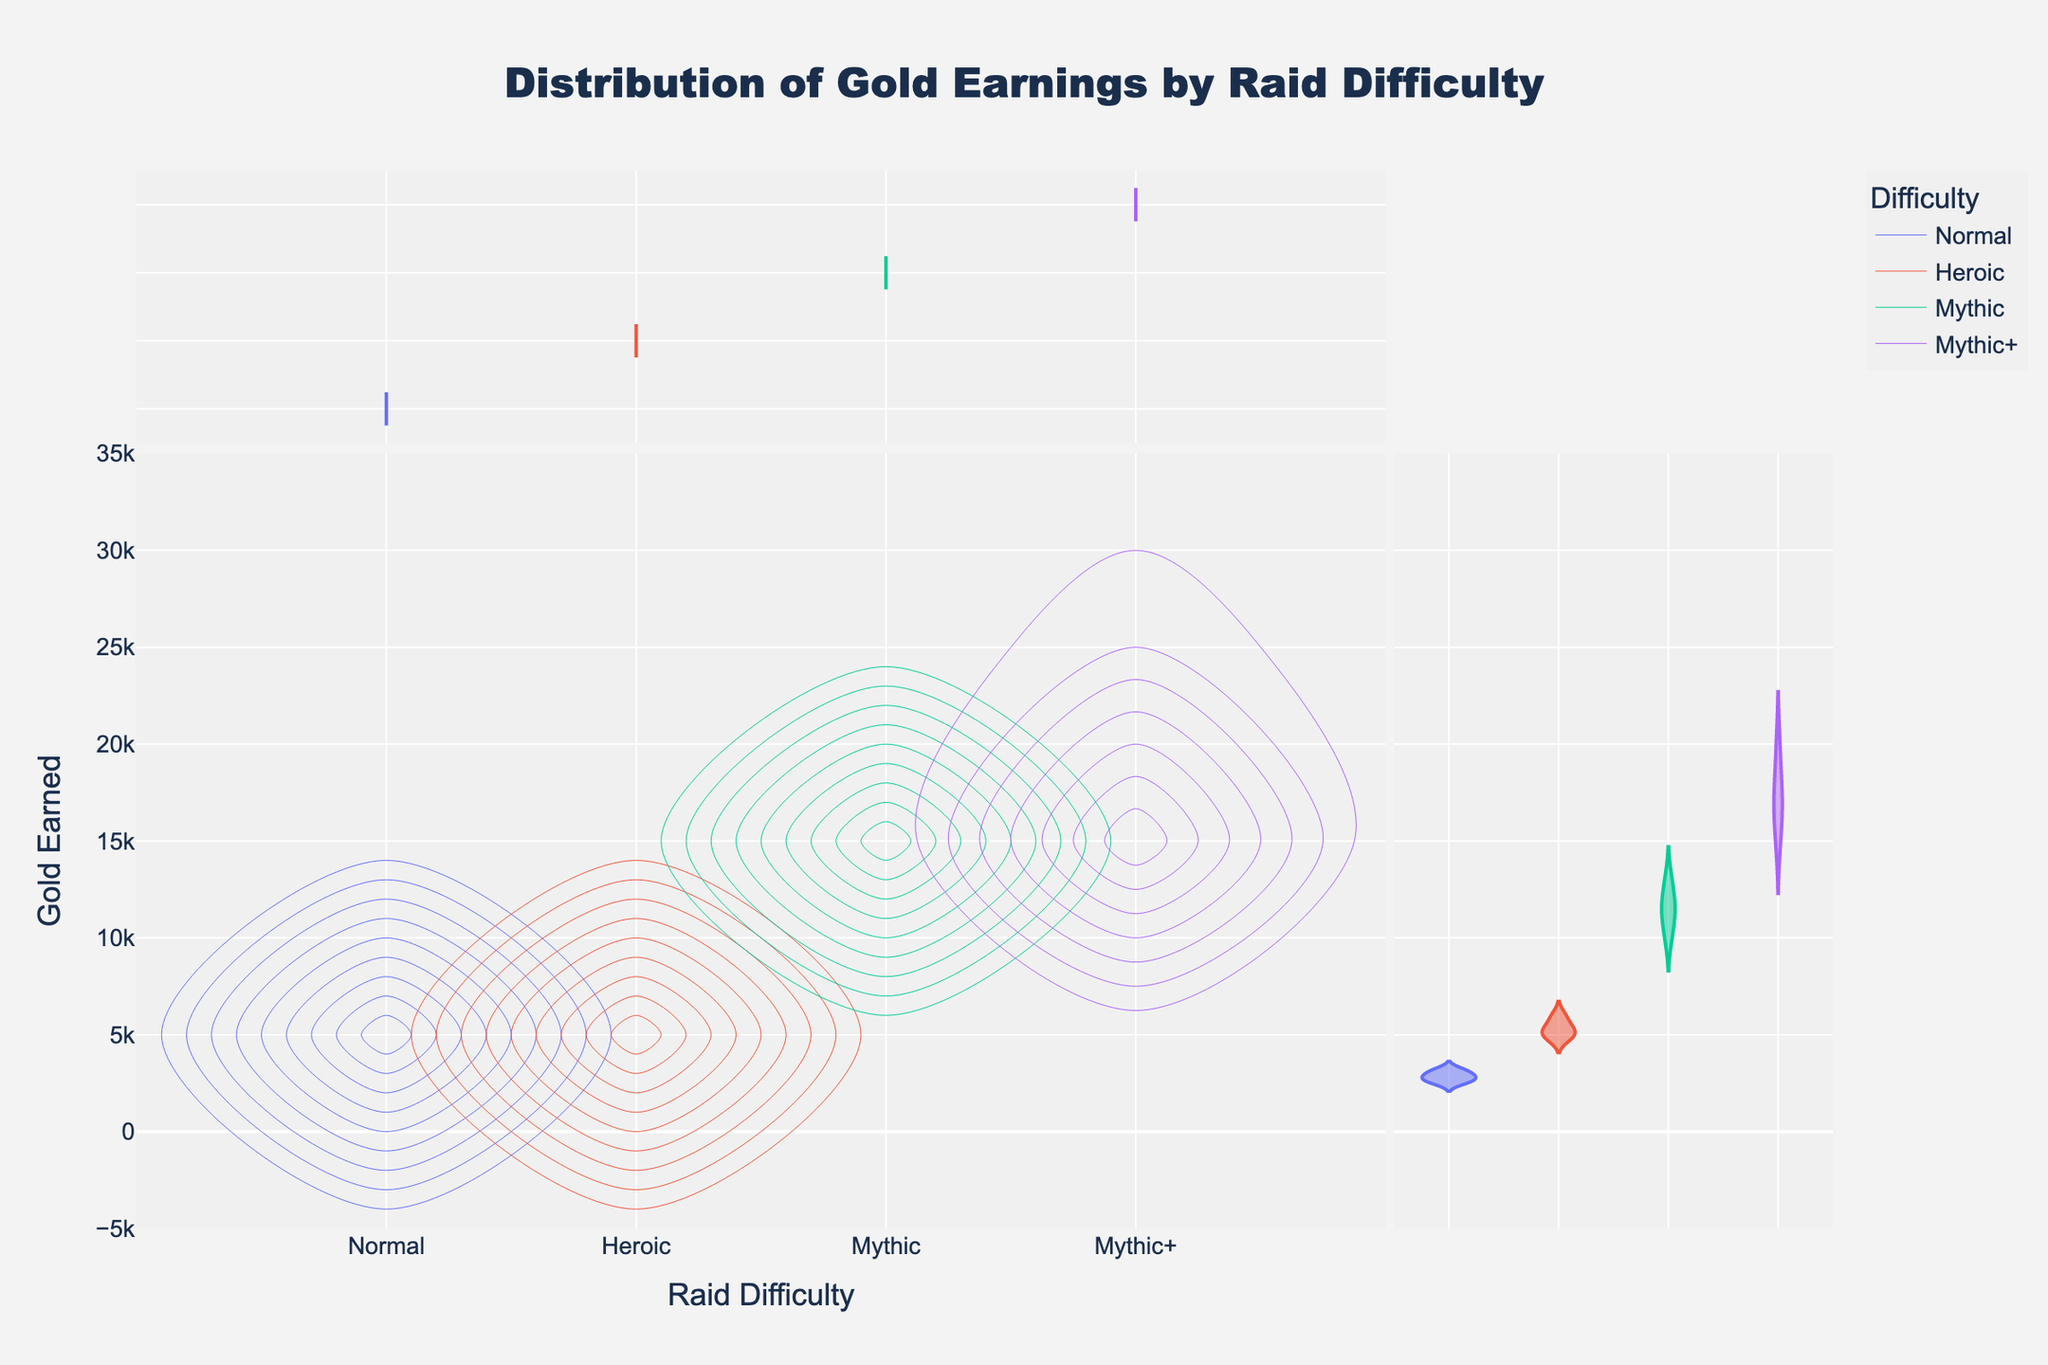What is the title of the plot? The title of the plot is located at the top center of the figure. By reading this text, you can understand the figure's main subject.
Answer: Distribution of Gold Earnings by Raid Difficulty How many different raid difficulties are displayed in the plot? The x-axis of the plot labels the different raid difficulties. Count the unique labels on this axis.
Answer: 4 Which raid difficulty has the highest maximum gold earned? By examining the y-axis distribution for each raid difficulty, you can see which has the highest maximum value. Mythic+ stands out with gold earned reaching up to 20,000.
Answer: Mythic+ What's the general range of gold earned for Normal raids? Look at the distribution on the y-axis for Normal difficulty to identify the range of values.
Answer: 2500 to 3200 Compare the gold earned distribution between Heroic and Mythic raids. Which one generally results in higher earnings? Compare the y-axis distributions for Heroic and Mythic difficulties. Note the central tendencies and ranges.
Answer: Mythic What's the Interquartile Range (IQR) of gold earnings for Heroic raid difficulty according to the box plot? The box plot included for each difficulty allows determination of the interquartile range, which is the range between the first (Q1) and third quartile (Q3). For Heroic, IQR is 1000 (6000-5000).
Answer: 1000 Does Mythic+ difficulty show a higher density peak for gold earnings compared to other difficulties? By comparing the density peaks of all difficulties, identify whether Mythic+ has the highest peak, indicative of a higher concentration of values.
Answer: Yes What is the density shape of gold earnings for Mythic difficulty, and what does it indicate? The shape of the density contour for Mythic difficulty, typically wider or narrower, gives an idea of the spread and concentration of the data points. A wider shape means more spread out values, while a narrower shape suggests concentrated values.
Answer: Wider, indicating more spread out values 